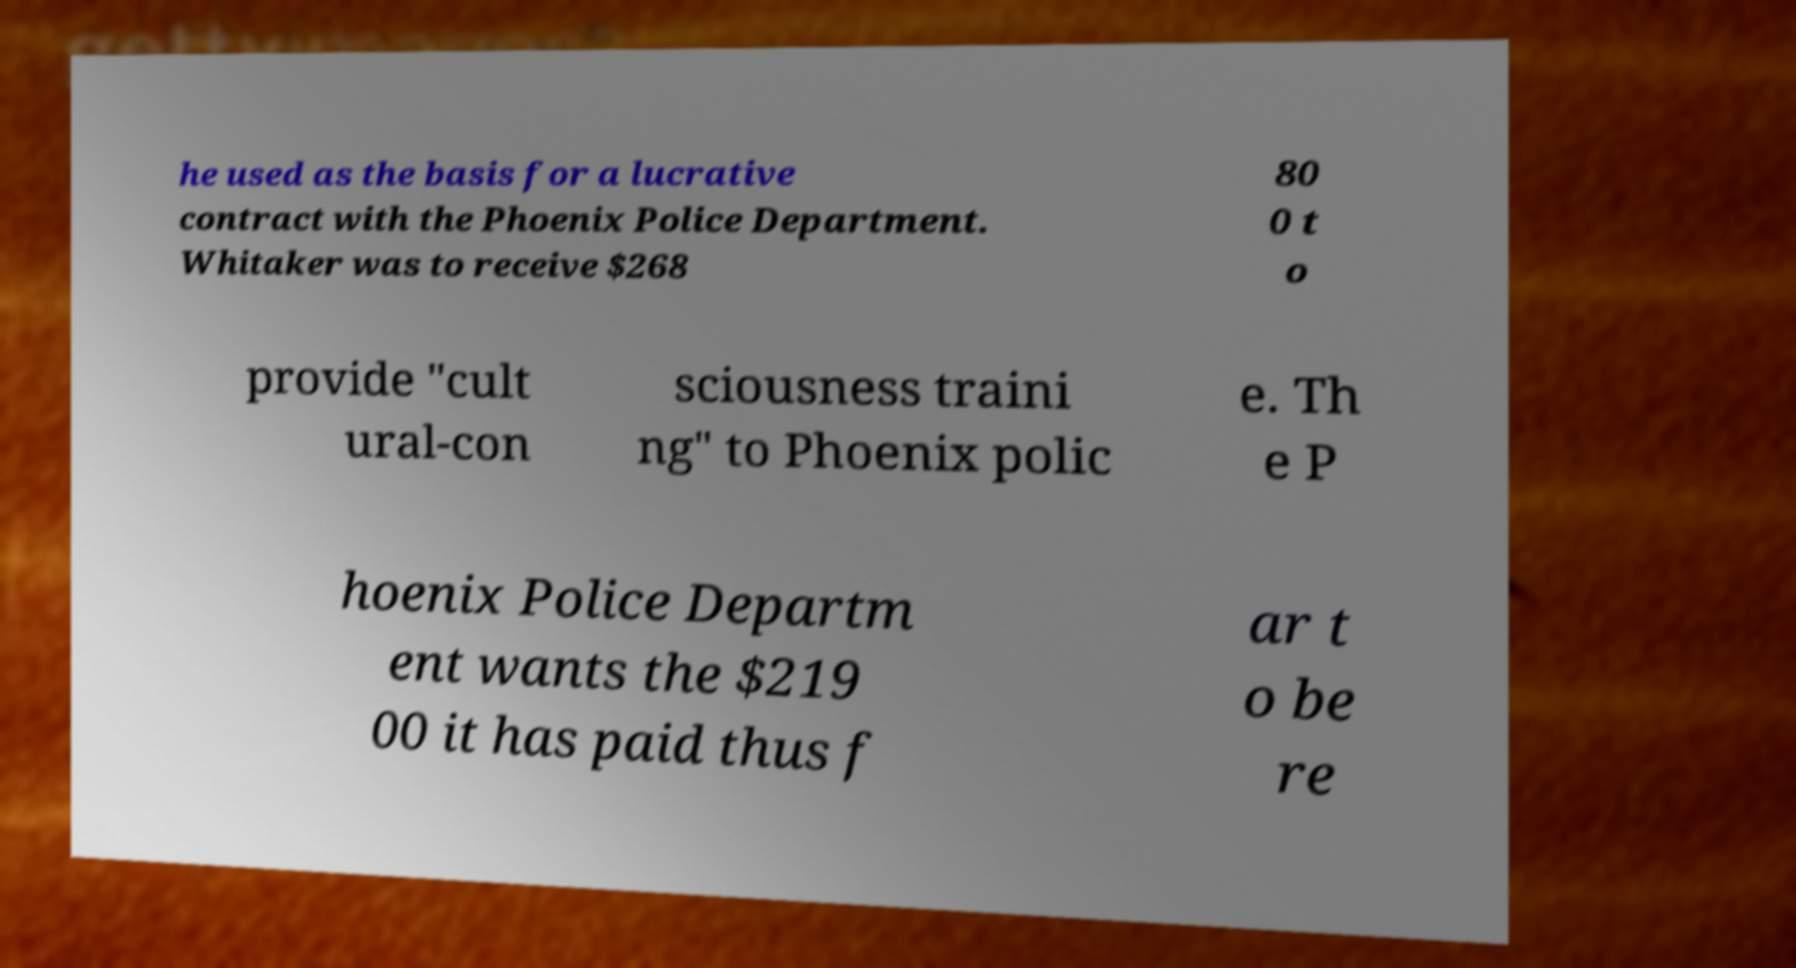I need the written content from this picture converted into text. Can you do that? he used as the basis for a lucrative contract with the Phoenix Police Department. Whitaker was to receive $268 80 0 t o provide "cult ural-con sciousness traini ng" to Phoenix polic e. Th e P hoenix Police Departm ent wants the $219 00 it has paid thus f ar t o be re 